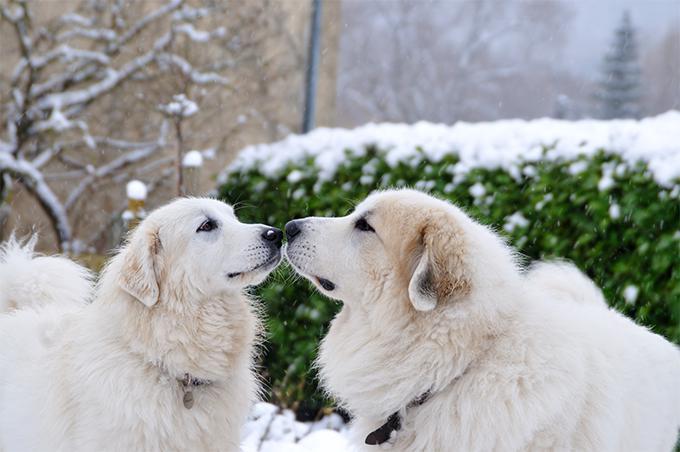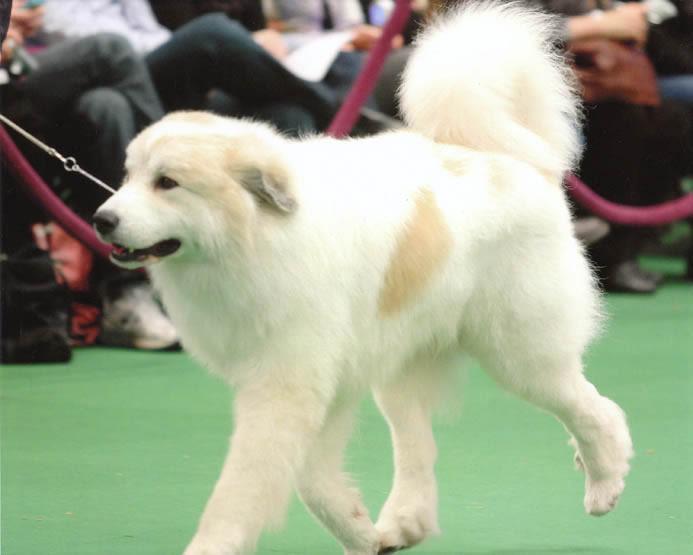The first image is the image on the left, the second image is the image on the right. Considering the images on both sides, is "There are three dogs." valid? Answer yes or no. Yes. The first image is the image on the left, the second image is the image on the right. Given the left and right images, does the statement "There are more than two dogs" hold true? Answer yes or no. Yes. 